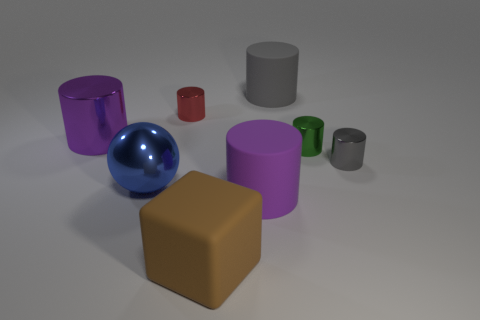Subtract all cyan blocks. How many purple cylinders are left? 2 Subtract 3 cylinders. How many cylinders are left? 3 Subtract all red cylinders. How many cylinders are left? 5 Subtract all large matte cylinders. How many cylinders are left? 4 Add 1 large matte blocks. How many objects exist? 9 Subtract all cyan cylinders. Subtract all yellow cubes. How many cylinders are left? 6 Subtract all cylinders. How many objects are left? 2 Add 5 tiny gray cylinders. How many tiny gray cylinders are left? 6 Add 7 gray cylinders. How many gray cylinders exist? 9 Subtract 0 gray cubes. How many objects are left? 8 